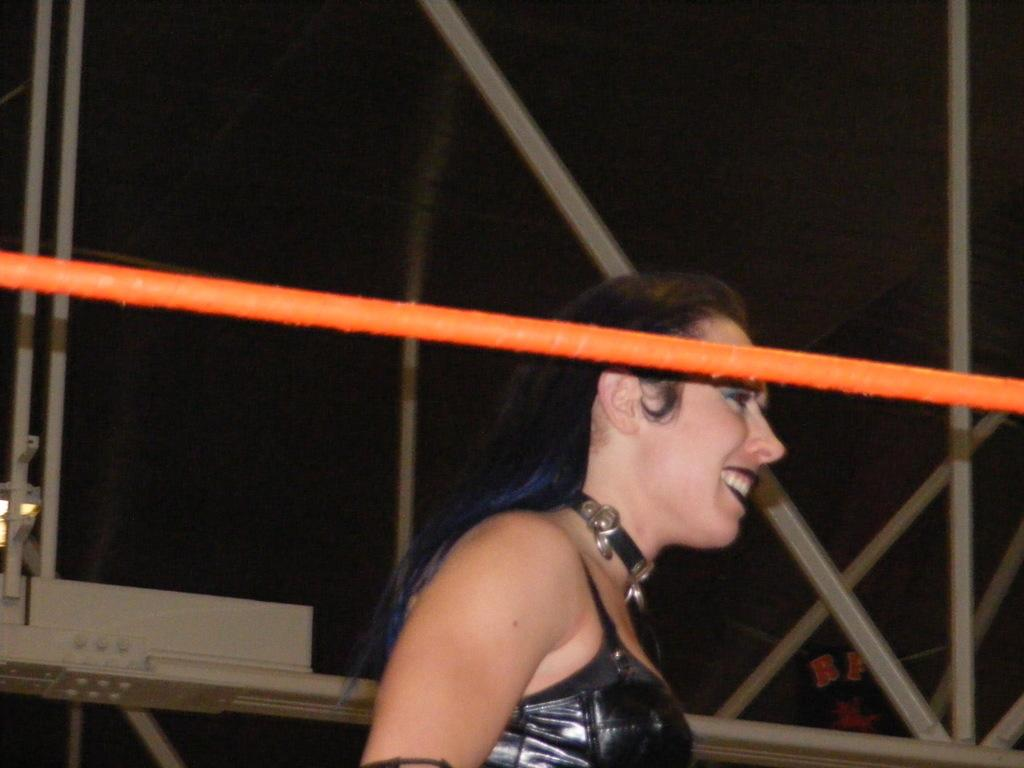Who is present in the image? There is a woman in the image. What is the woman doing in the image? The woman is smiling. What objects can be seen in the image besides the woman? There are rods in the image. What can be said about the background of the image? The background of the image is dark. What type of plants can be seen growing in the image? There are no plants visible in the image. What wish does the woman have while she is smiling in the image? There is no information about the woman's wishes in the image. 